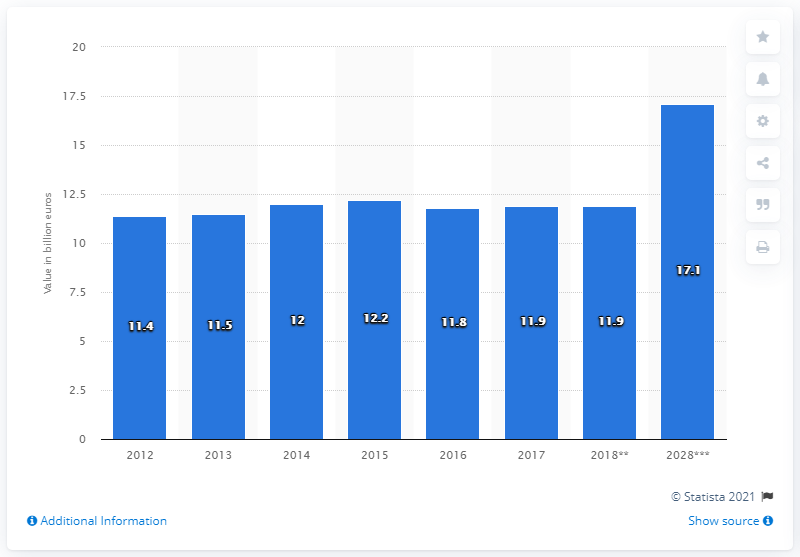Point out several critical features in this image. In 2017, the value of visitor exports in Belgium was 11.9 million. 